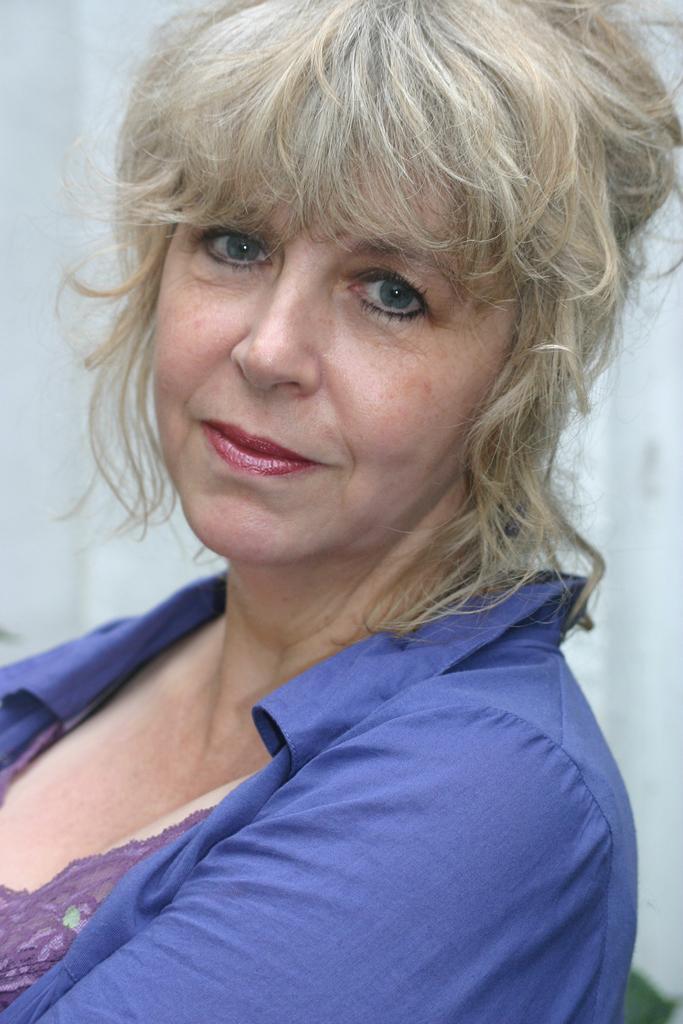Could you give a brief overview of what you see in this image? In this image there is a woman wearing a blue shirt. Behind her there is a wall. 